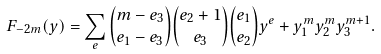<formula> <loc_0><loc_0><loc_500><loc_500>F _ { - 2 m } ( y ) = \sum _ { e } { m - e _ { 3 } \choose e _ { 1 } - e _ { 3 } } { e _ { 2 } + 1 \choose e _ { 3 } } { e _ { 1 } \choose e _ { 2 } } y ^ { e } + y _ { 1 } ^ { m } y _ { 2 } ^ { m } y _ { 3 } ^ { m + 1 } .</formula> 